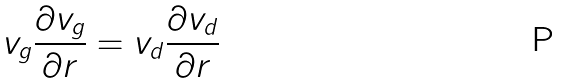Convert formula to latex. <formula><loc_0><loc_0><loc_500><loc_500>v _ { g } \frac { \partial v _ { g } } { \partial r } = v _ { d } \frac { \partial v _ { d } } { \partial r }</formula> 